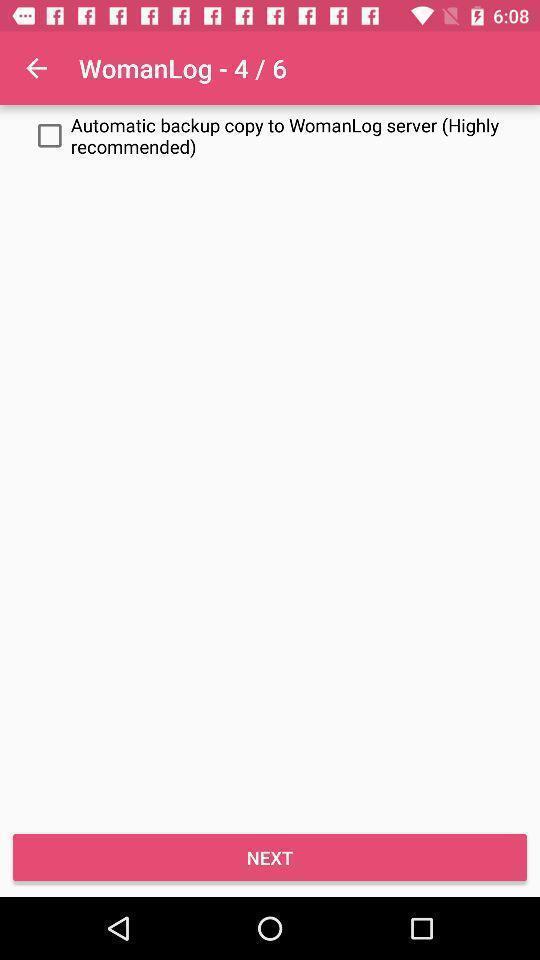Tell me about the visual elements in this screen capture. Page with an option for fertility tracker application. 